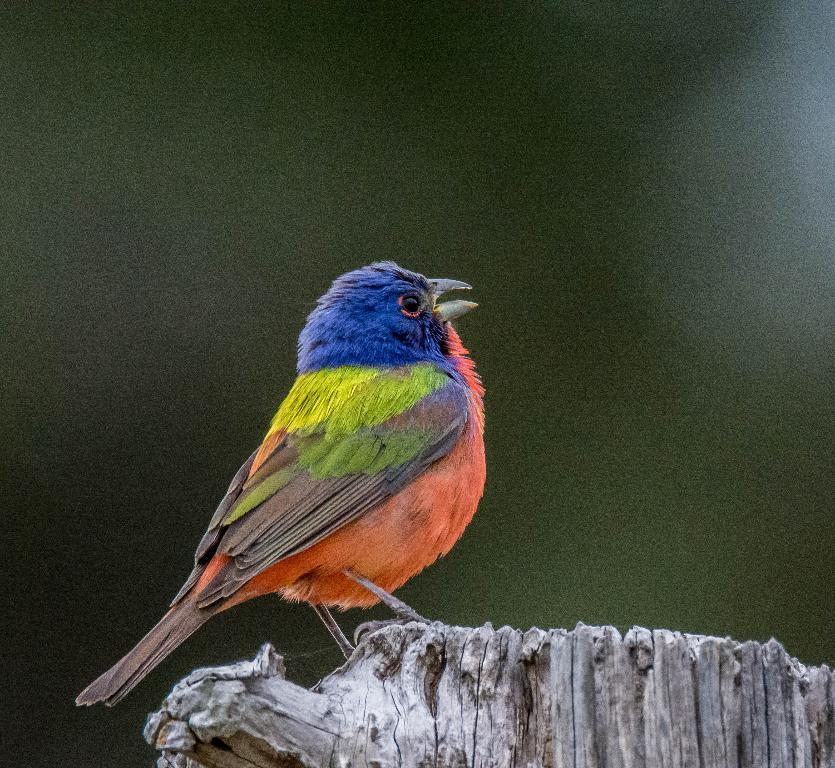What type of animal can be seen in the image? There is a bird in the image. Where is the bird located? The bird is on a wooden object. Can you describe the background of the image? The background of the image is blurry. What color is the vein visible in the bird's wing in the image? There is no vein visible in the bird's wing in the image. Can you see the sea in the background of the image? There is no sea visible in the background of the image. 